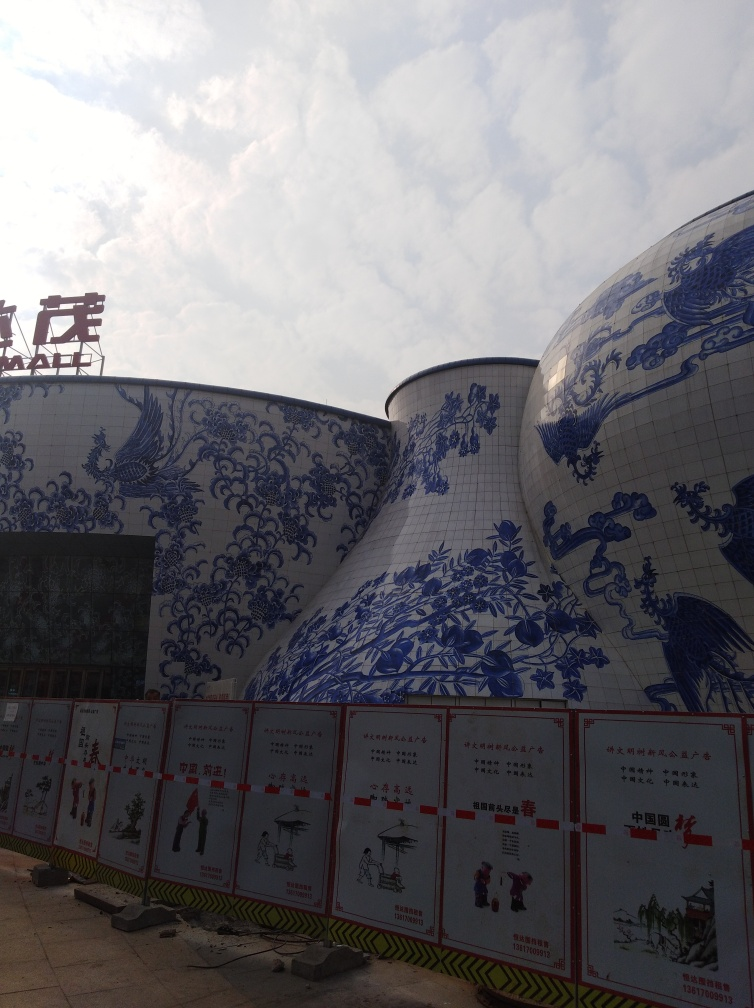Is there any motion blur in the image? After examining the image closely, I can confirm that there is no motion blur present. The structures and the signs are in sharp focus, with clear lines and no signs of streaking or smearing that would suggest movement during the capture of the photograph. 